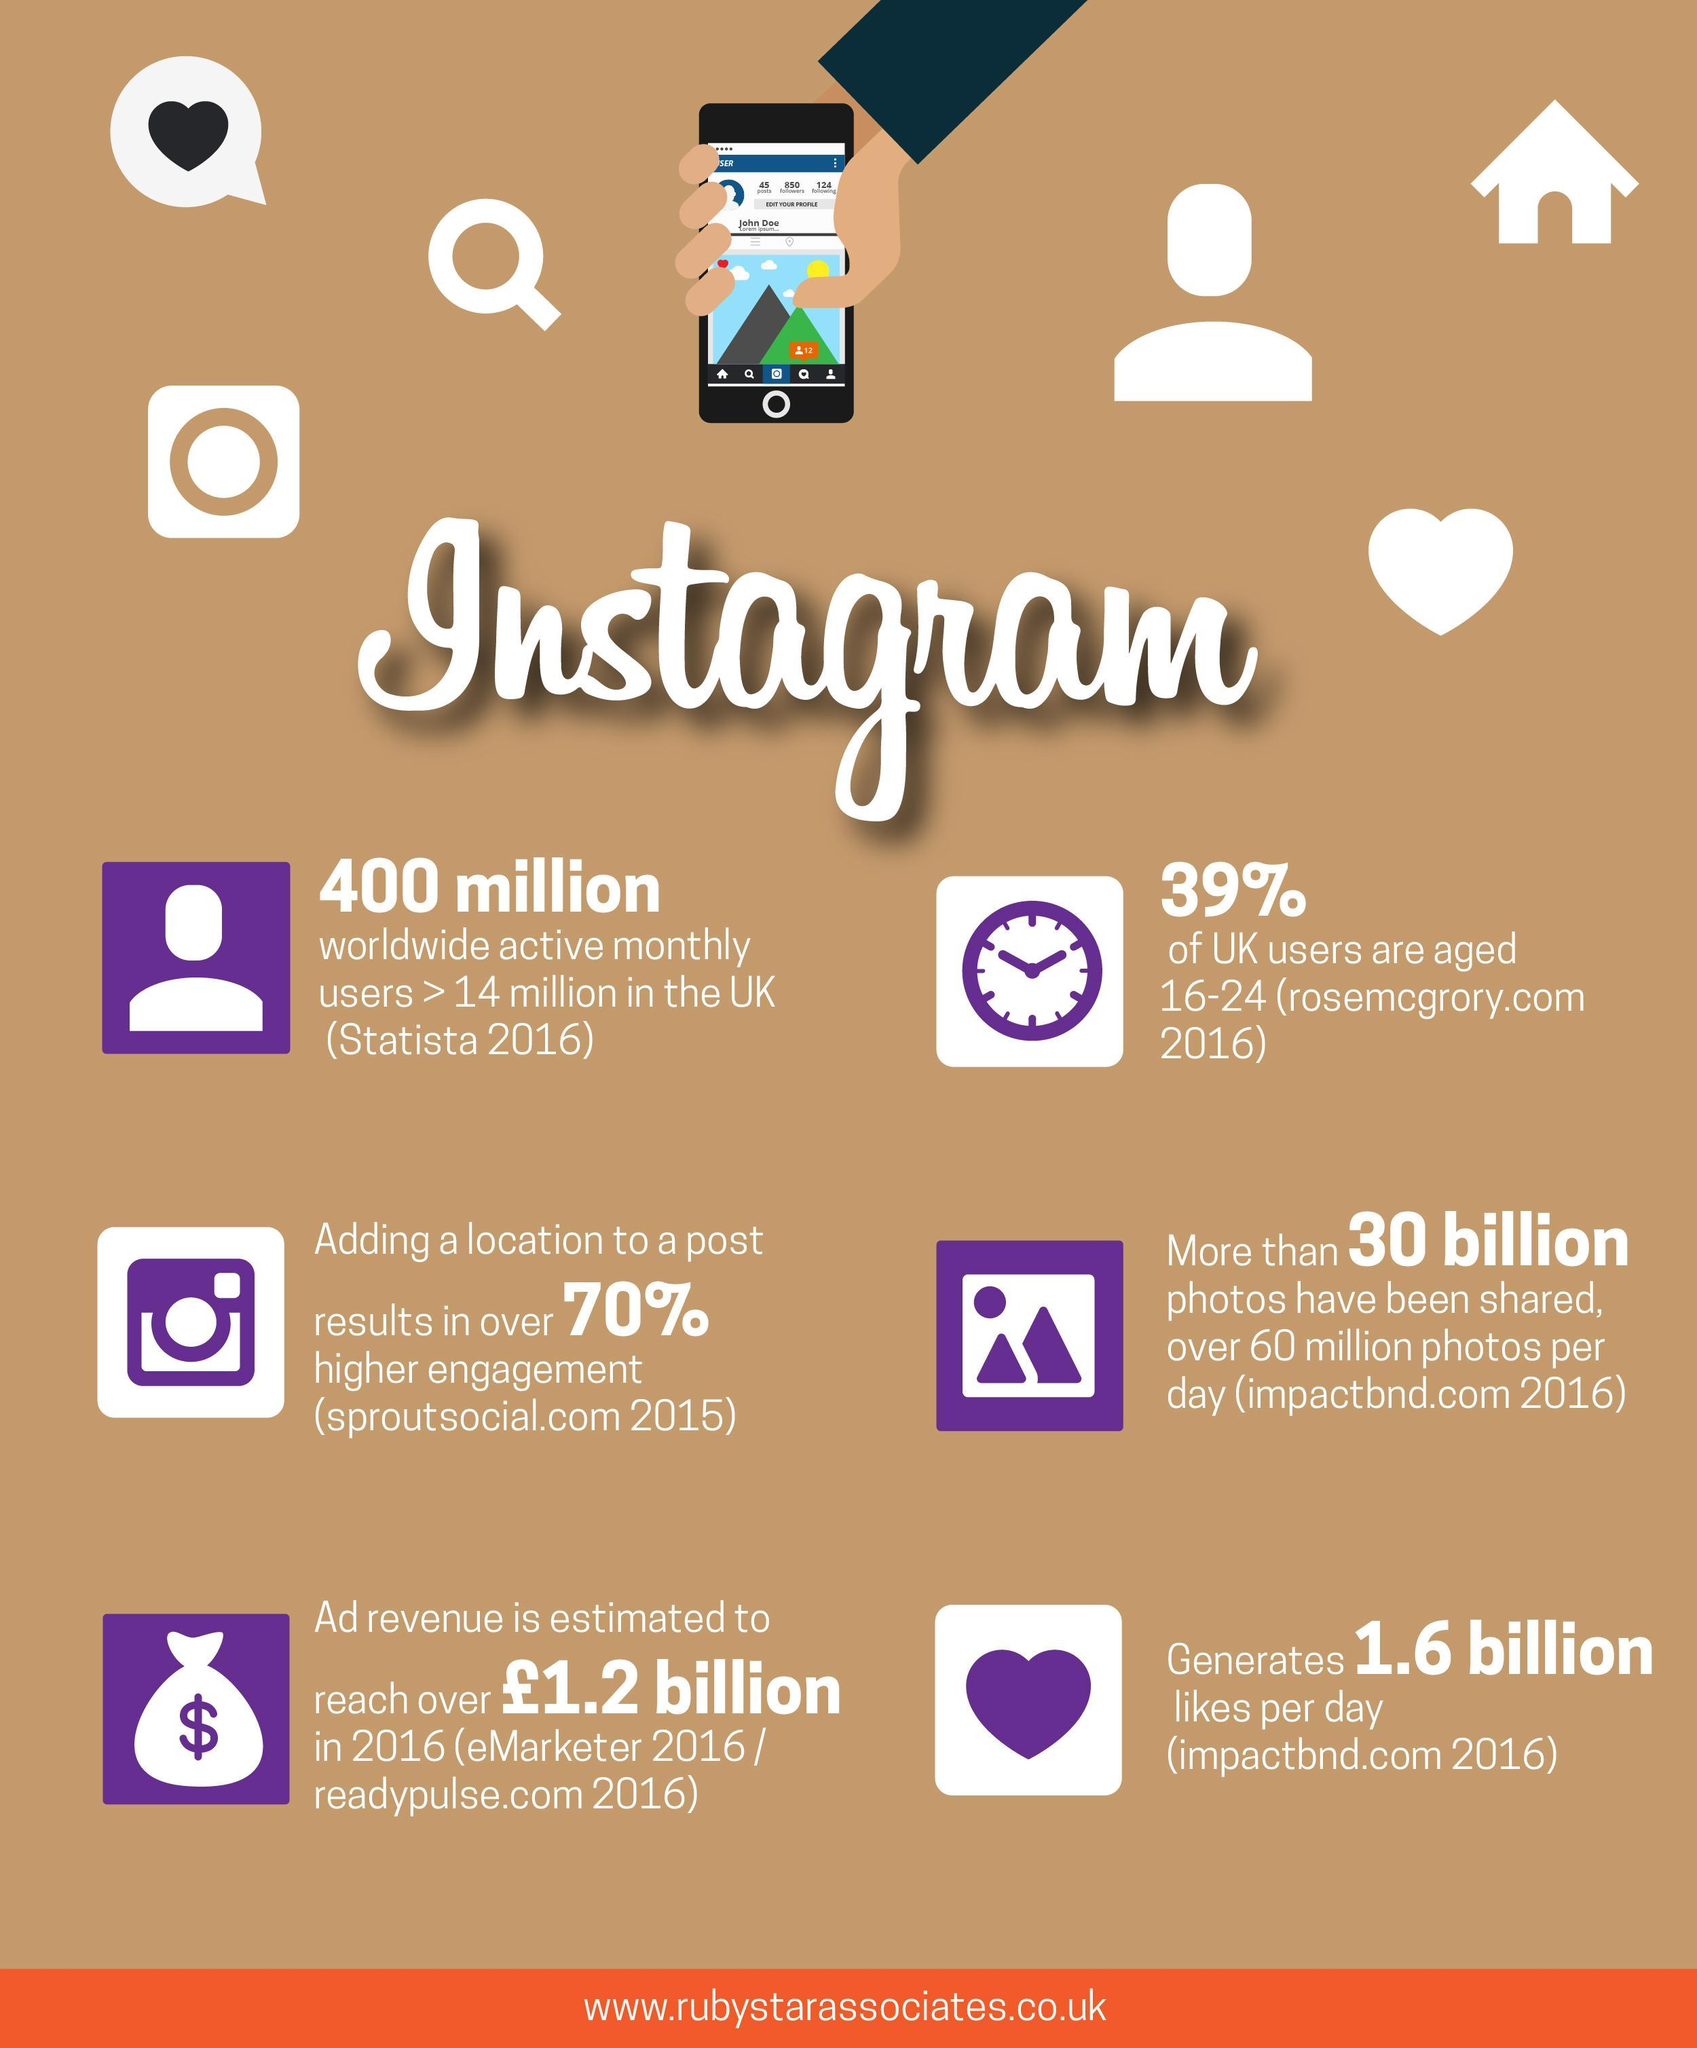What should be provided with an Instagram post to make it more engaged?
Answer the question with a short phrase. Adding a location How many photos have been shared through Instagram so far? 30 billion What is the score of Likes of Instagram posts a day? 1.6 billion What percentage of Instagram Users in UK are not in the age category 16-24? 61 